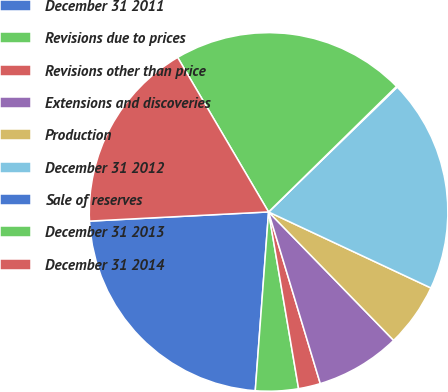<chart> <loc_0><loc_0><loc_500><loc_500><pie_chart><fcel>December 31 2011<fcel>Revisions due to prices<fcel>Revisions other than price<fcel>Extensions and discoveries<fcel>Production<fcel>December 31 2012<fcel>Sale of reserves<fcel>December 31 2013<fcel>December 31 2014<nl><fcel>23.0%<fcel>3.86%<fcel>1.98%<fcel>7.63%<fcel>5.74%<fcel>19.23%<fcel>0.09%<fcel>21.11%<fcel>17.35%<nl></chart> 